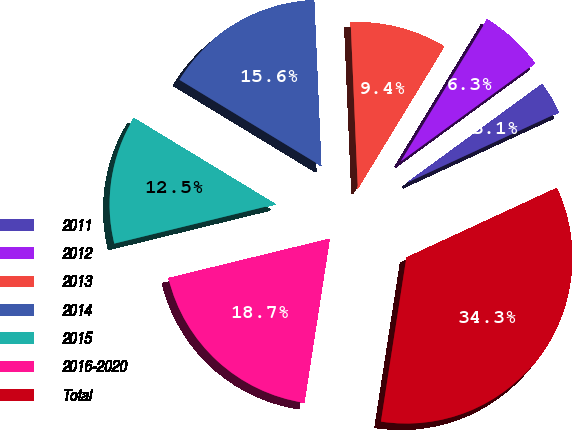Convert chart. <chart><loc_0><loc_0><loc_500><loc_500><pie_chart><fcel>2011<fcel>2012<fcel>2013<fcel>2014<fcel>2015<fcel>2016-2020<fcel>Total<nl><fcel>3.14%<fcel>6.26%<fcel>9.38%<fcel>15.62%<fcel>12.5%<fcel>18.74%<fcel>34.34%<nl></chart> 